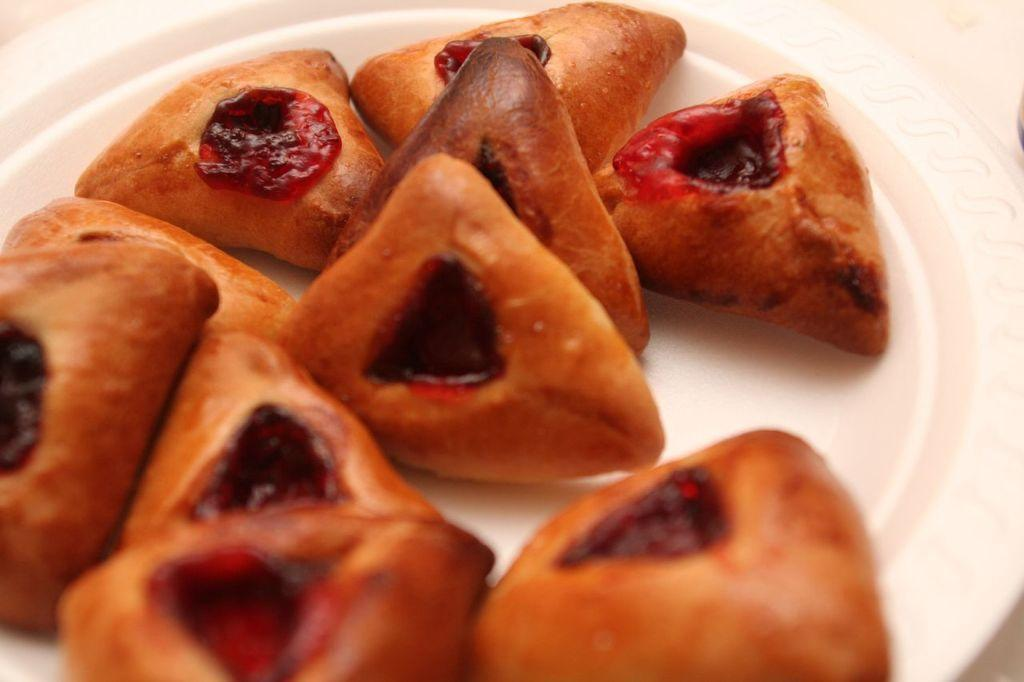What is present on the plate in the image? There are food items placed on a plate in the image. What type of office furniture can be seen in the image? There is no office furniture present in the image; it only shows food items placed on a plate. How many elbows are visible in the image? There are no elbows visible in the image; it only shows food items placed on a plate. 